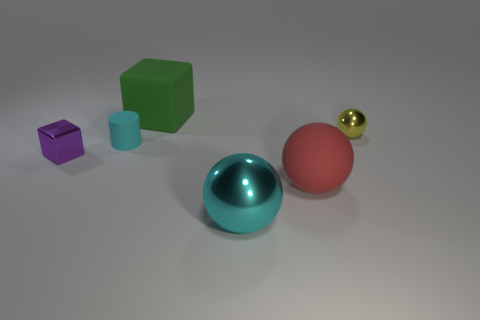Add 4 small purple balls. How many objects exist? 10 Subtract all large cyan metallic spheres. How many spheres are left? 2 Subtract all purple blocks. How many blocks are left? 1 Subtract all cylinders. How many objects are left? 5 Subtract 1 cubes. How many cubes are left? 1 Subtract all red cylinders. Subtract all brown balls. How many cylinders are left? 1 Subtract all green cubes. How many yellow balls are left? 1 Subtract all big blue cylinders. Subtract all tiny metallic objects. How many objects are left? 4 Add 5 green things. How many green things are left? 6 Add 3 red matte balls. How many red matte balls exist? 4 